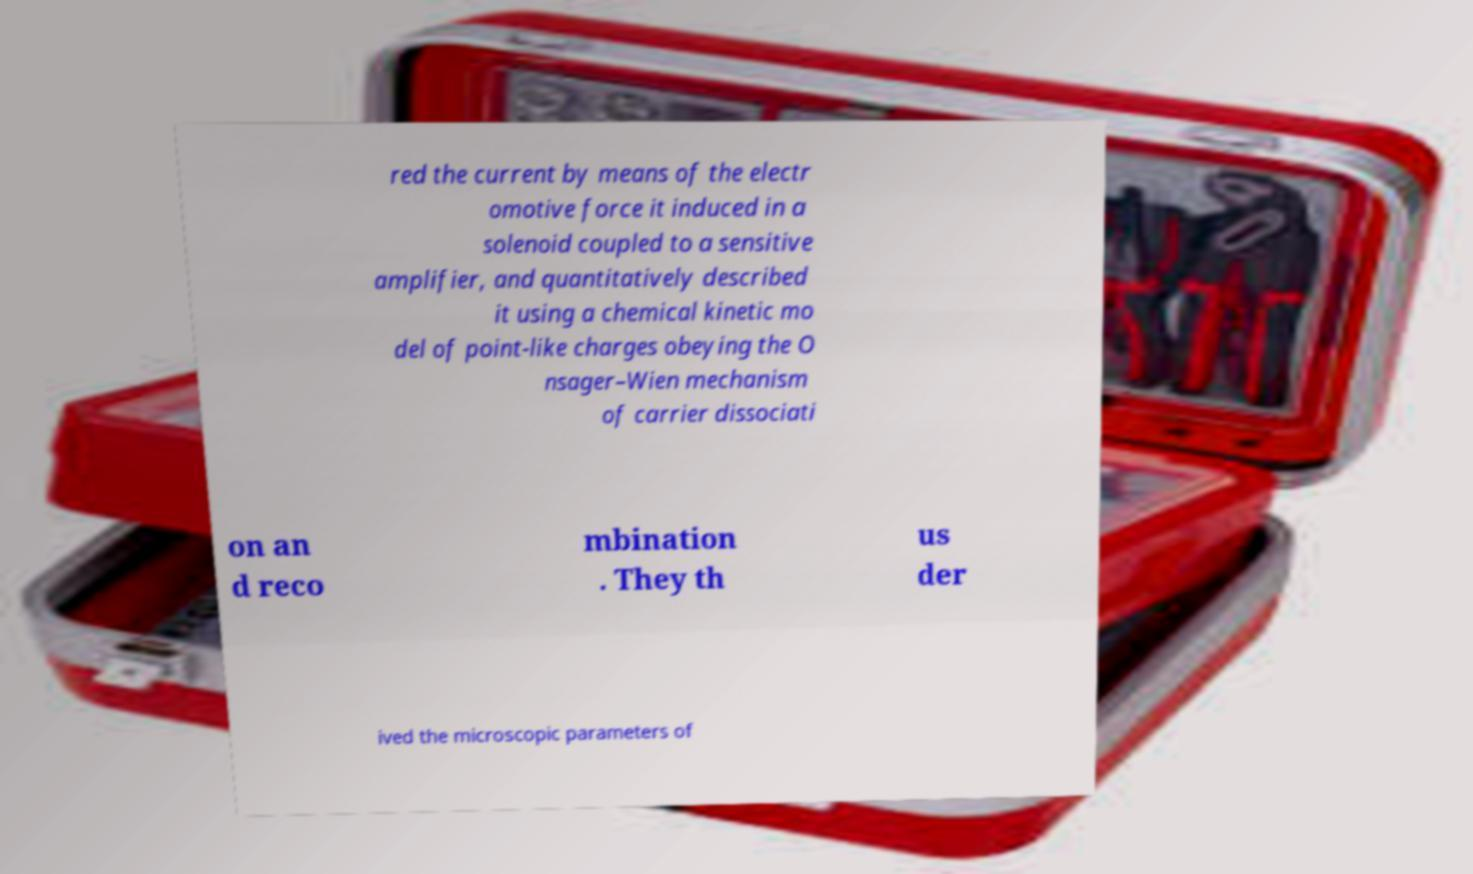For documentation purposes, I need the text within this image transcribed. Could you provide that? red the current by means of the electr omotive force it induced in a solenoid coupled to a sensitive amplifier, and quantitatively described it using a chemical kinetic mo del of point-like charges obeying the O nsager–Wien mechanism of carrier dissociati on an d reco mbination . They th us der ived the microscopic parameters of 